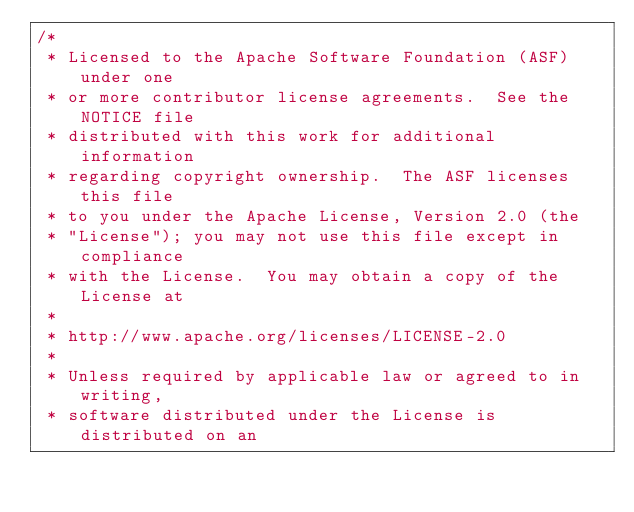Convert code to text. <code><loc_0><loc_0><loc_500><loc_500><_Java_>/*
 * Licensed to the Apache Software Foundation (ASF) under one
 * or more contributor license agreements.  See the NOTICE file
 * distributed with this work for additional information
 * regarding copyright ownership.  The ASF licenses this file
 * to you under the Apache License, Version 2.0 (the
 * "License"); you may not use this file except in compliance
 * with the License.  You may obtain a copy of the License at
 *
 * http://www.apache.org/licenses/LICENSE-2.0
 *
 * Unless required by applicable law or agreed to in writing,
 * software distributed under the License is distributed on an</code> 